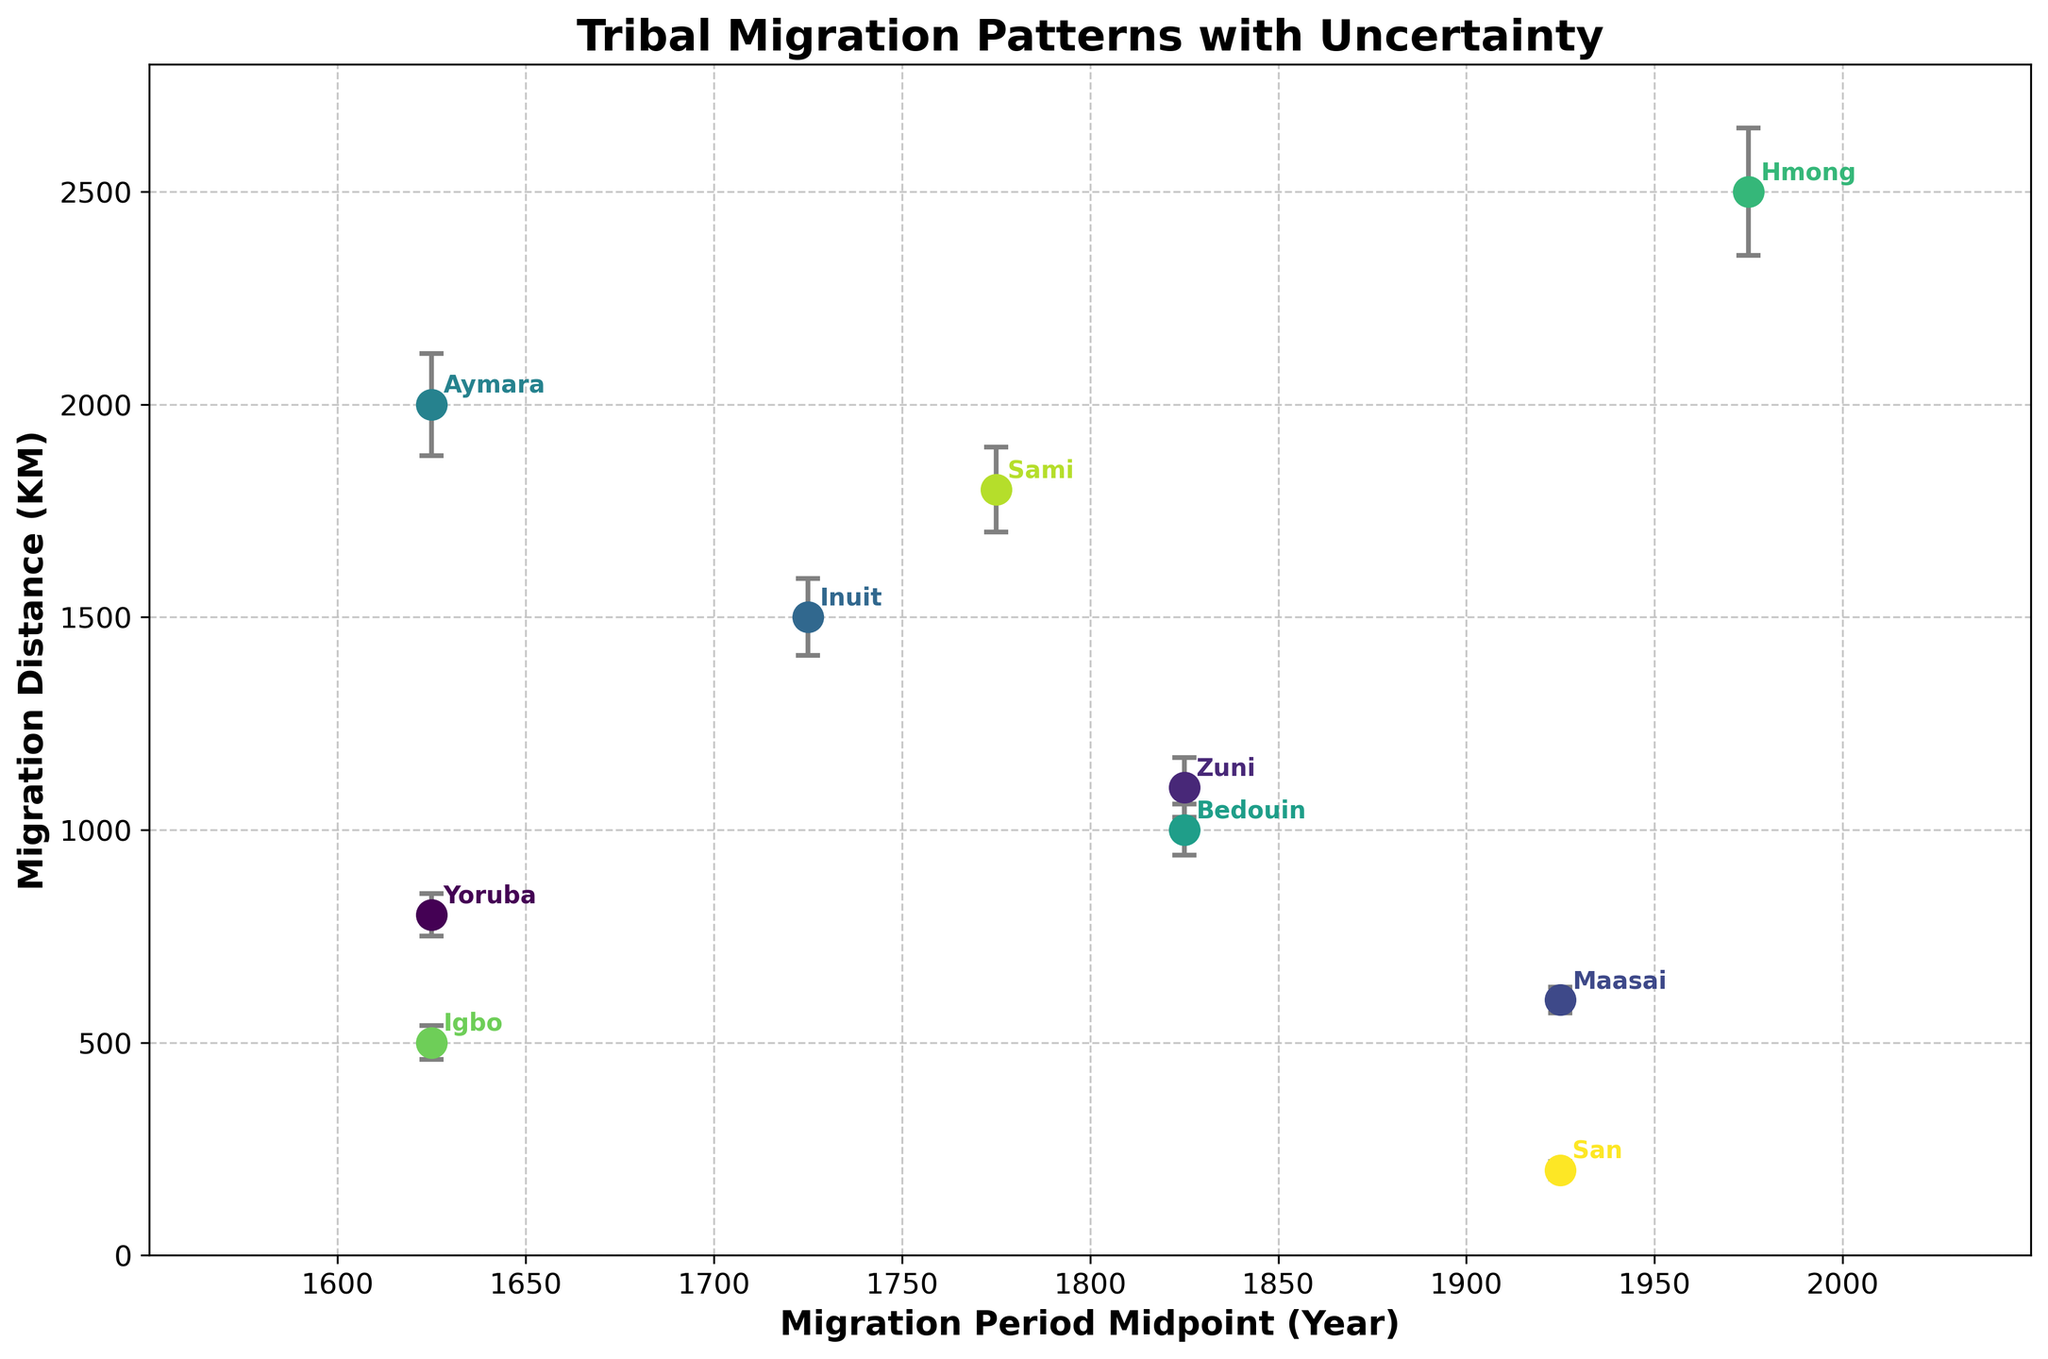Which tribe has the longest migration distance? By looking at the y-axis values, we see that the Aymara tribe has the highest migration distance marked at 2000 kilometers.
Answer: Aymara What is the midpoint year of migration for the Zuni tribe? The midpoint year is calculated by taking the average of the Migration Start Year and Migration End Year for the Zuni tribe, which is (1800 + 1850) / 2 = 1825.
Answer: 1825 Which tribe has the smallest estimated error in migration distance? By comparing the length of the error bars, the San tribe has the smallest error, which is 20 kilometers.
Answer: San How does the migration distance of the Maasai tribe compare to that of the Yoruba tribe? The Maasai tribe's migration distance is 600 kilometers, while the Yoruba tribe's distance is 800 kilometers, making the Yoruba tribe's migration longer.
Answer: Yoruba's distance is longer Among the tribes that migrated between 1600 and 1650, which tribe covered the smallest distance? The tribes that migrated between 1600 and 1650 are Yoruba, Aymara, and Igbo. By comparing their distances, Igbo covered the smallest at 500 kilometers.
Answer: Igbo What is the difference in migration distances between the Hmong and the Inuit tribes? The Hmong tribe's migration distance is 2500 kilometers, while the Inuit tribe's distance is 1500 kilometers. The difference is 2500 - 1500 = 1000 kilometers.
Answer: 1000 kilometers Which tribe has the highest uncertainty in its migration distance? By comparing the lengths of the error bars, the Hmong tribe has the highest uncertainty in migration distance at 150 kilometers.
Answer: Hmong What are the x-axis and y-axis representing in this figure? The x-axis represents the midpoint year of the migration period, and the y-axis represents the migration distance in kilometers.
Answer: Midpoint year of migration period, migration distance in kilometers From the visual, how can you tell which color corresponds to which tribe? Each data point is color-coded and annotated with the tribe's name next to it, making it easy to match the color to the corresponding tribe.
Answer: Color-coded and annotated What is the range of years shown on the x-axis? The x-axis ranges from 1550 to 2050, as indicated by the tick marks on the axis.
Answer: 1550 to 2050 